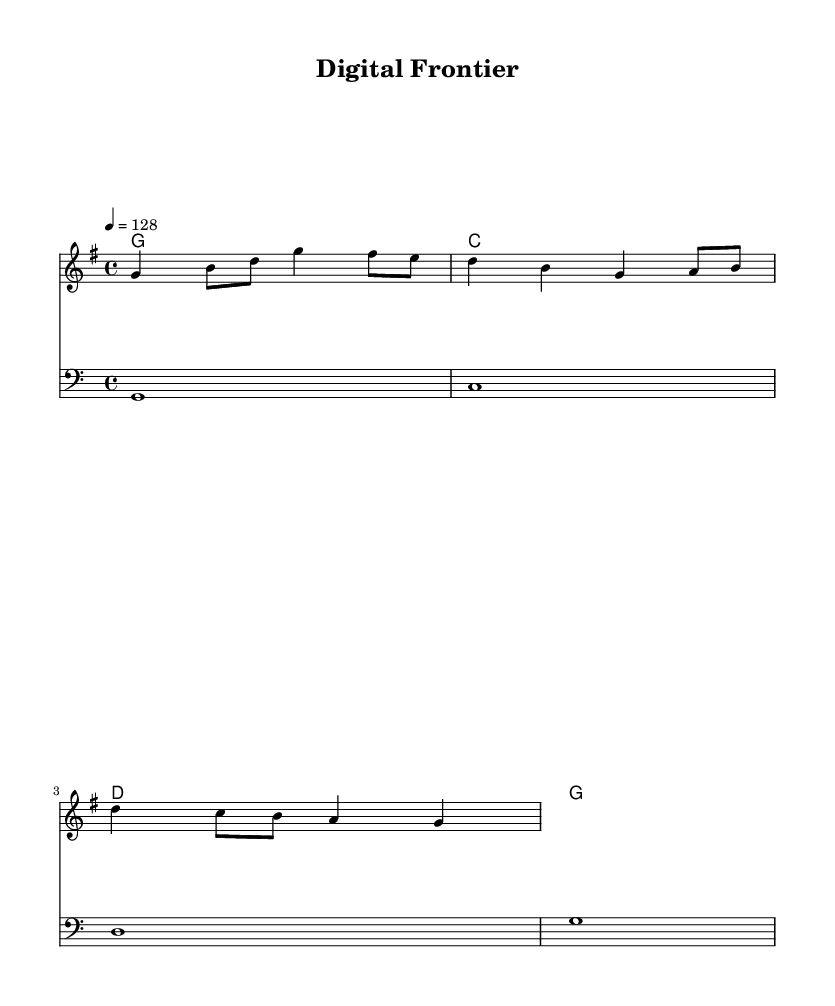What is the key signature of this music? The key signature is G major, which has one sharp (F#).
Answer: G major What is the time signature of the piece? The time signature is found at the beginning of the staff and is indicated as 4/4, meaning four beats per measure with a quarter note getting one beat.
Answer: 4/4 What is the tempo marking for the music? The tempo marking indicates that the music should be played at a speed of 128 beats per minute, noted as "4 = 128" in the score.
Answer: 128 How many measures are there in the melody? The melody consists of four measures, which can be counted by looking at the notation and the bar lines separating each measure.
Answer: 4 What are the chord changes in the harmonies? The chords change sequentially from G to C to D and back to G, as noted in the chord mode section of the music.
Answer: G, C, D, G What is the lyrical theme of the song? The lyrics celebrate the concept of the digital frontier, suggesting innovation, light, and technology with imagery of circuits and stars.
Answer: Digital frontier What musical genre does this piece represent? The song is characterized as an upbeat country tune, highlighting elements typical of country music, such as a simple structure and themes related to innovation.
Answer: Country 